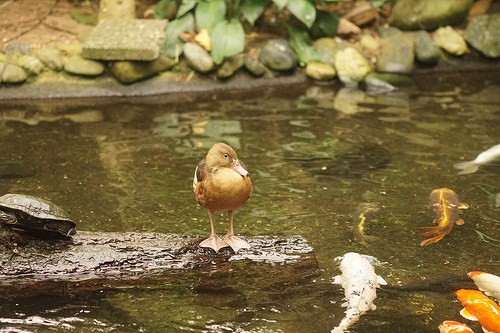<image>
Is there a bird on the water? No. The bird is not positioned on the water. They may be near each other, but the bird is not supported by or resting on top of the water. Is the duck in the water? No. The duck is not contained within the water. These objects have a different spatial relationship. 